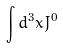<formula> <loc_0><loc_0><loc_500><loc_500>\int d ^ { 3 } x J ^ { 0 }</formula> 